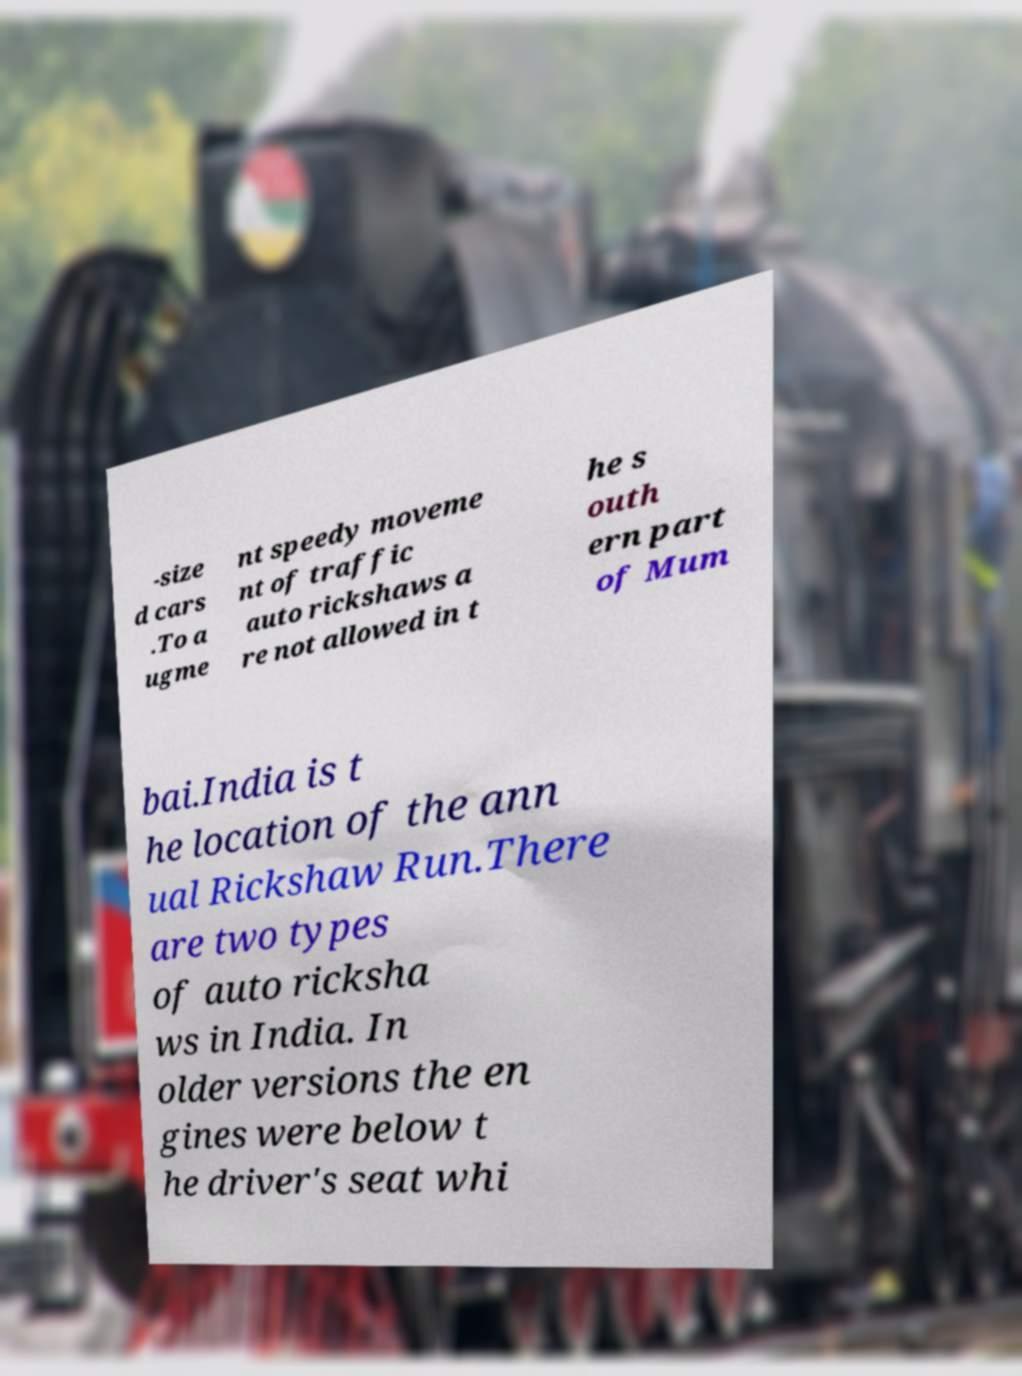Could you extract and type out the text from this image? -size d cars .To a ugme nt speedy moveme nt of traffic auto rickshaws a re not allowed in t he s outh ern part of Mum bai.India is t he location of the ann ual Rickshaw Run.There are two types of auto ricksha ws in India. In older versions the en gines were below t he driver's seat whi 